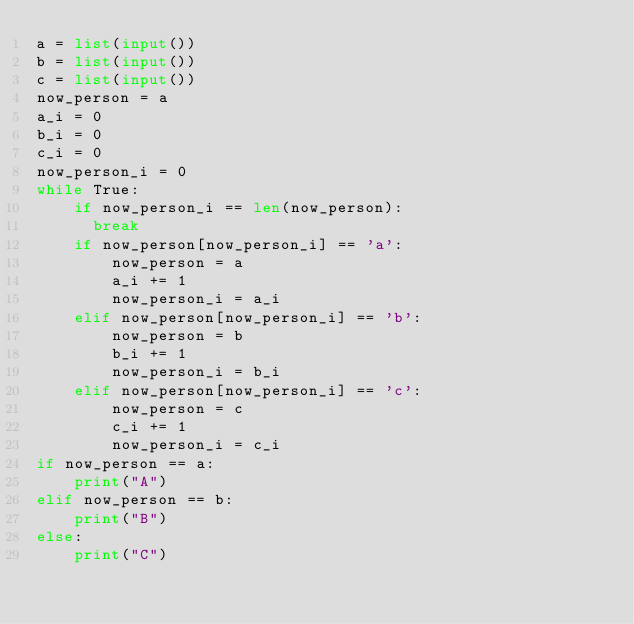Convert code to text. <code><loc_0><loc_0><loc_500><loc_500><_Python_>a = list(input())
b = list(input())
c = list(input())
now_person = a
a_i = 0
b_i = 0
c_i = 0
now_person_i = 0
while True:
    if now_person_i == len(now_person):
      break
    if now_person[now_person_i] == 'a':
        now_person = a
        a_i += 1
        now_person_i = a_i
    elif now_person[now_person_i] == 'b':
        now_person = b
        b_i += 1
        now_person_i = b_i
    elif now_person[now_person_i] == 'c':
        now_person = c
        c_i += 1
        now_person_i = c_i
if now_person == a:
    print("A")
elif now_person == b:
    print("B")
else:
    print("C")</code> 